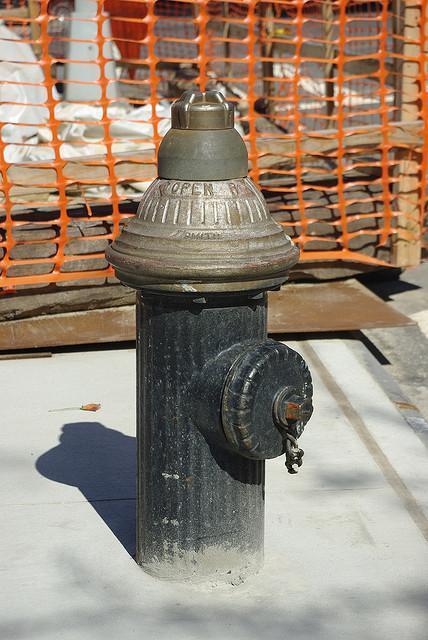How many fire hydrants are there?
Give a very brief answer. 1. 